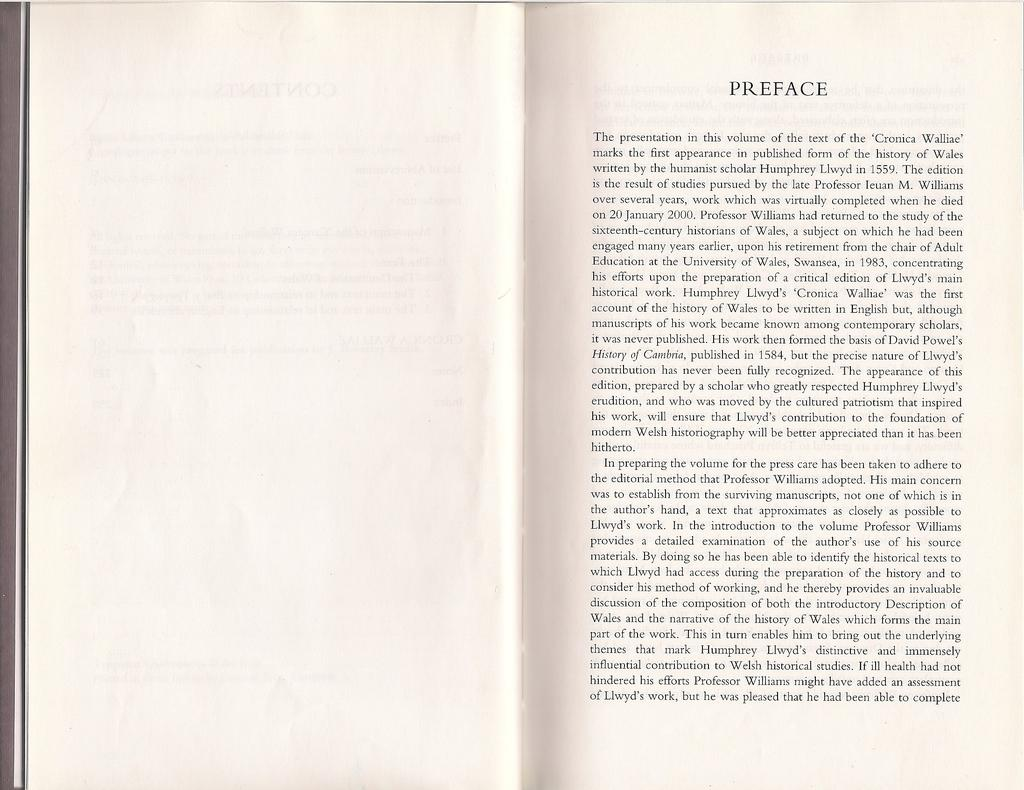What is depicted in the image? There are pages of a book in the image. Can you describe the text in the image? There is text written to the right side of the image. What type of flesh can be seen being prepared for dinner in the image? There is no flesh or dinner preparation present in the image; it only features pages of a book and text. 